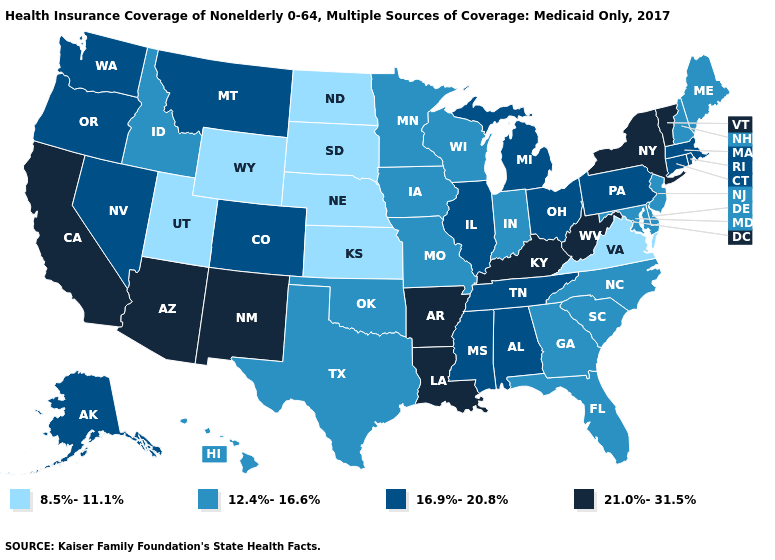What is the value of New Jersey?
Quick response, please. 12.4%-16.6%. What is the value of Maine?
Write a very short answer. 12.4%-16.6%. Among the states that border Tennessee , does North Carolina have the highest value?
Give a very brief answer. No. What is the value of Hawaii?
Concise answer only. 12.4%-16.6%. What is the highest value in states that border Indiana?
Concise answer only. 21.0%-31.5%. What is the lowest value in states that border Iowa?
Concise answer only. 8.5%-11.1%. What is the value of Tennessee?
Give a very brief answer. 16.9%-20.8%. What is the value of Washington?
Be succinct. 16.9%-20.8%. Does the first symbol in the legend represent the smallest category?
Concise answer only. Yes. What is the lowest value in the USA?
Quick response, please. 8.5%-11.1%. What is the value of Georgia?
Write a very short answer. 12.4%-16.6%. Does Louisiana have the same value as Oklahoma?
Answer briefly. No. What is the highest value in states that border New Jersey?
Quick response, please. 21.0%-31.5%. 